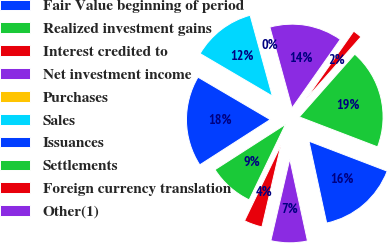Convert chart to OTSL. <chart><loc_0><loc_0><loc_500><loc_500><pie_chart><fcel>Fair Value beginning of period<fcel>Realized investment gains<fcel>Interest credited to<fcel>Net investment income<fcel>Purchases<fcel>Sales<fcel>Issuances<fcel>Settlements<fcel>Foreign currency translation<fcel>Other(1)<nl><fcel>15.79%<fcel>19.3%<fcel>1.75%<fcel>14.03%<fcel>0.0%<fcel>12.28%<fcel>17.54%<fcel>8.77%<fcel>3.51%<fcel>7.02%<nl></chart> 